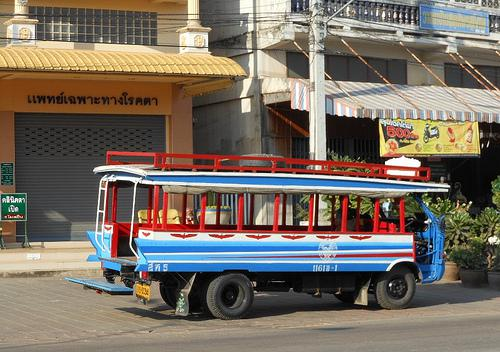Question: how many vehicles are in the picture?
Choices:
A. 2.
B. 3.
C. 4.
D. 1.
Answer with the letter. Answer: D Question: what color is the building on the left?
Choices:
A. Blue.
B. Brown.
C. Yellow.
D. White.
Answer with the letter. Answer: C Question: where is the vehicle parked?
Choices:
A. In the garage.
B. In the parking space.
C. On a street.
D. On the curb.
Answer with the letter. Answer: C 